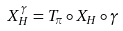Convert formula to latex. <formula><loc_0><loc_0><loc_500><loc_500>X _ { H } ^ { \gamma } = T _ { \pi } \circ X _ { H } \circ \gamma</formula> 